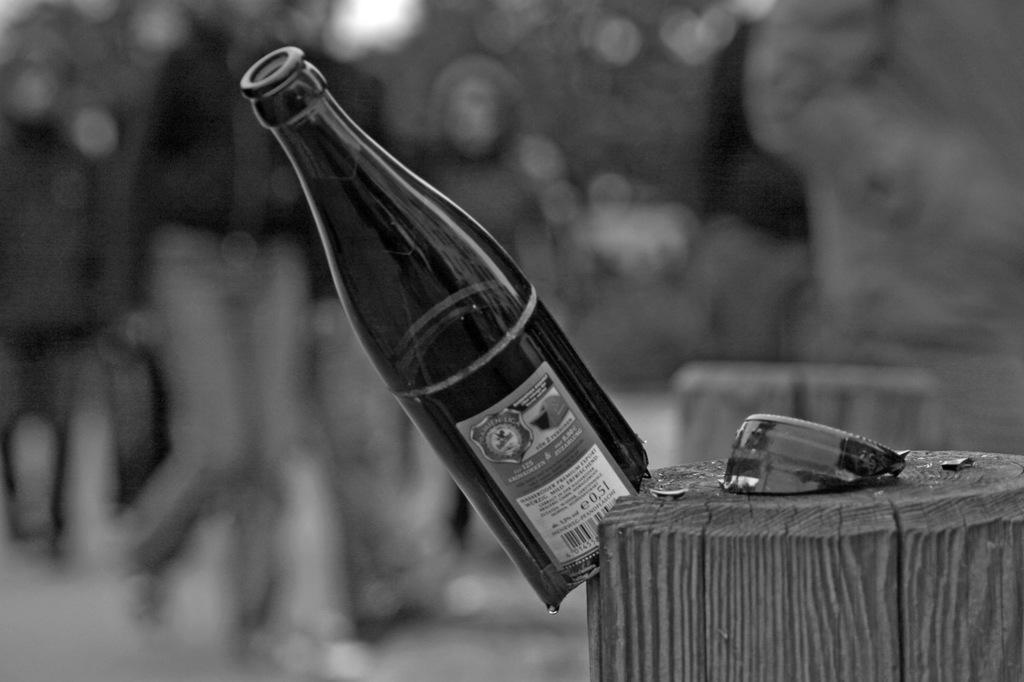Describe this image in one or two sentences. This is a black and white image. We can see a broken glass bottle, At the bottom right corner of the image, there is a wooden object. Behind the bottle there is the blurred background. 